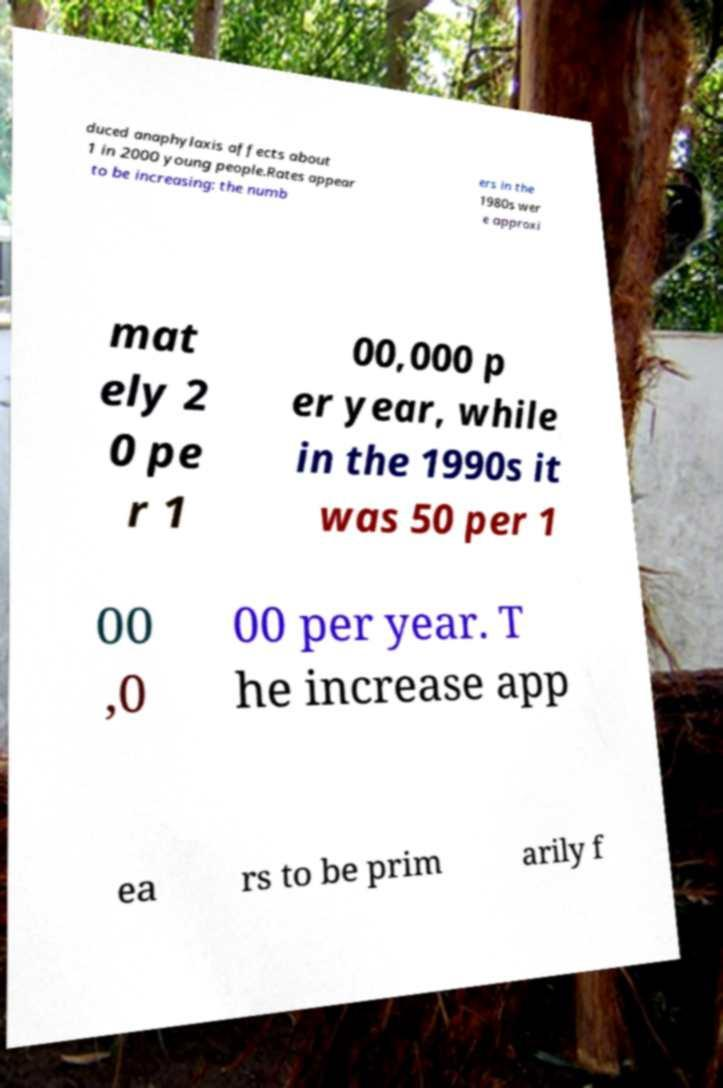What messages or text are displayed in this image? I need them in a readable, typed format. duced anaphylaxis affects about 1 in 2000 young people.Rates appear to be increasing: the numb ers in the 1980s wer e approxi mat ely 2 0 pe r 1 00,000 p er year, while in the 1990s it was 50 per 1 00 ,0 00 per year. T he increase app ea rs to be prim arily f 